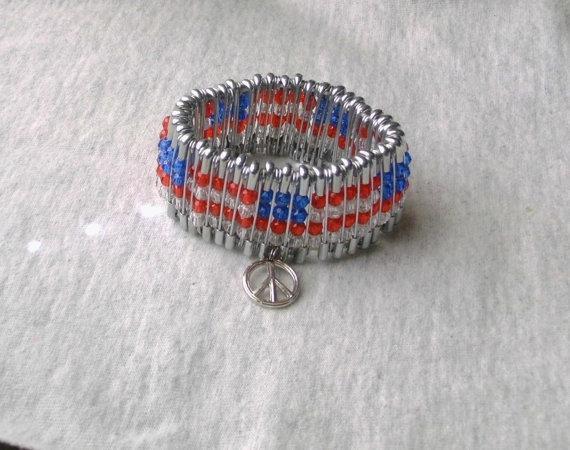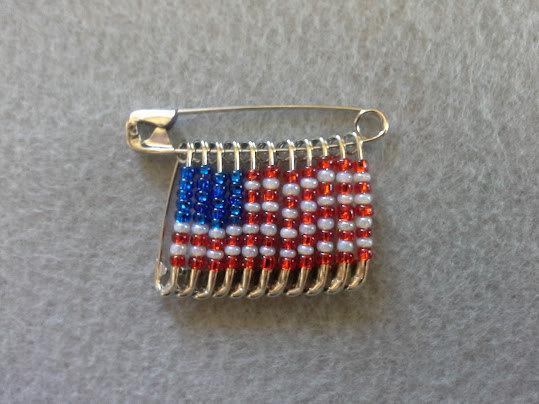The first image is the image on the left, the second image is the image on the right. Examine the images to the left and right. Is the description "At least one image shows pins with beads forming an American flag pattern." accurate? Answer yes or no. Yes. 